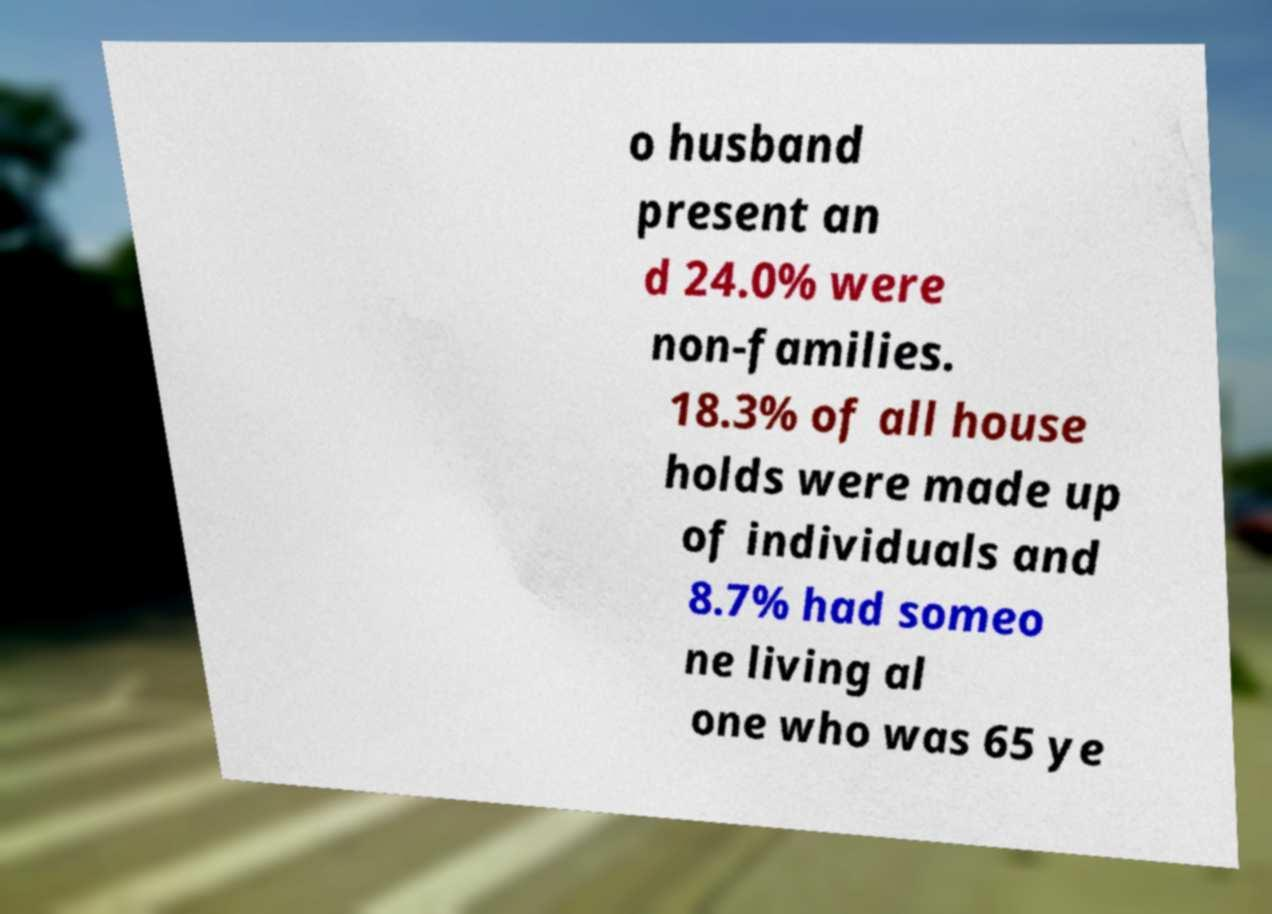Could you assist in decoding the text presented in this image and type it out clearly? o husband present an d 24.0% were non-families. 18.3% of all house holds were made up of individuals and 8.7% had someo ne living al one who was 65 ye 